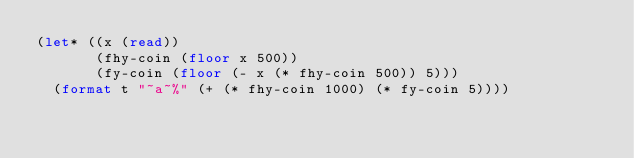Convert code to text. <code><loc_0><loc_0><loc_500><loc_500><_Lisp_>(let* ((x (read))
       (fhy-coin (floor x 500))
       (fy-coin (floor (- x (* fhy-coin 500)) 5)))
  (format t "~a~%" (+ (* fhy-coin 1000) (* fy-coin 5))))
</code> 